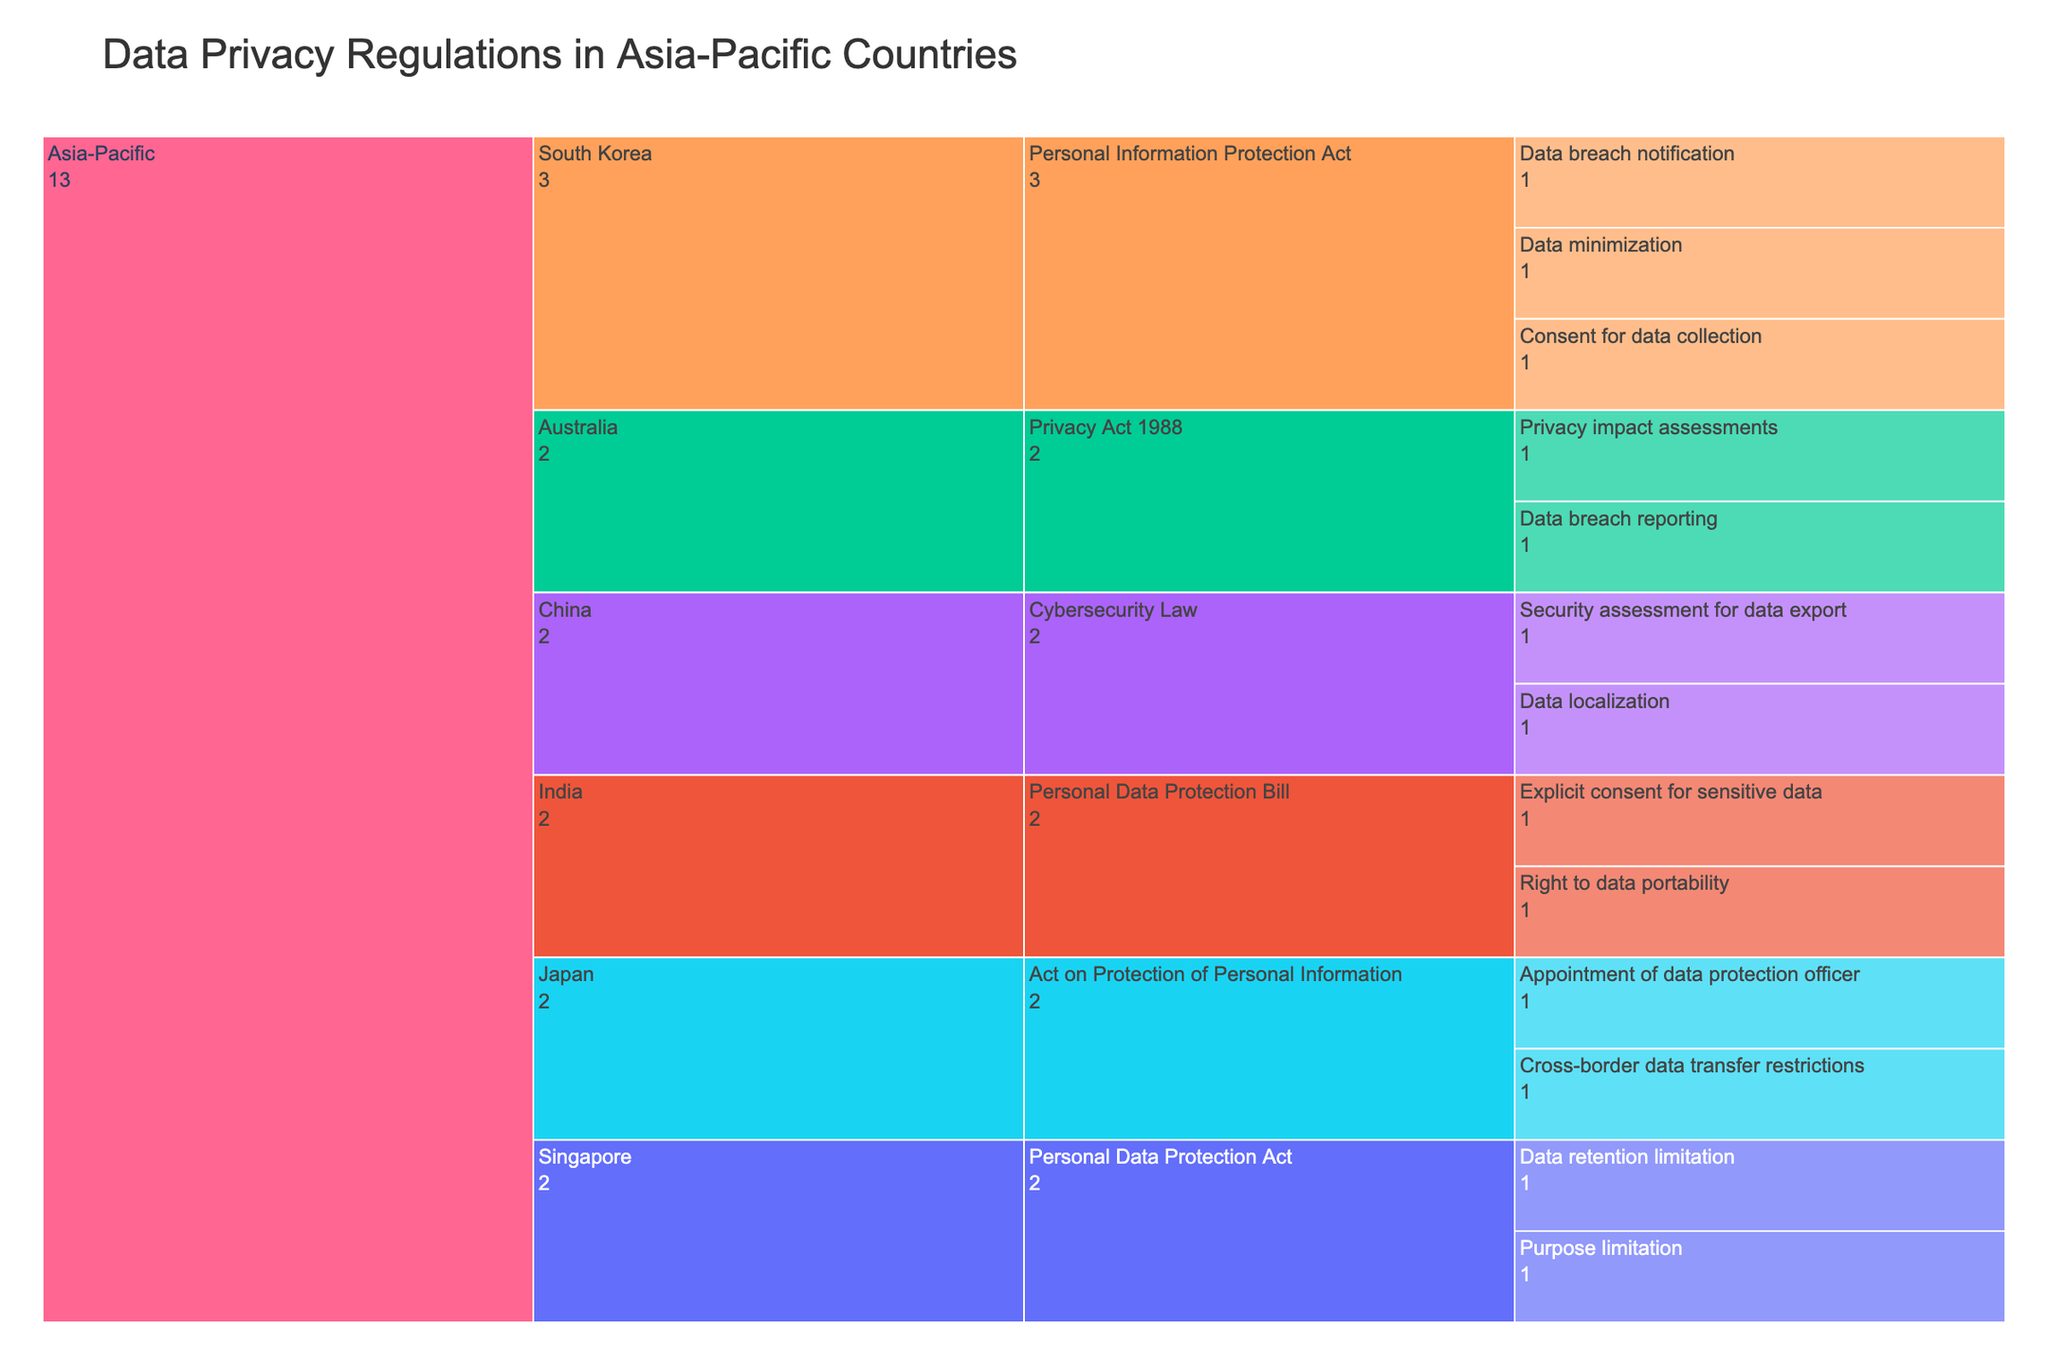What is the title of the Icicle Chart? The title is displayed at the top of the chart and typically summarizes the content it represents. This chart’s title is "Data Privacy Regulations in Asia-Pacific Countries".
Answer: Data Privacy Regulations in Asia-Pacific Countries Which country has the regulation "Personal Information Protection Act"? The chart shows regulations categorized by country. Follow the path from the Region (Asia-Pacific) to each country until you find the regulation "Personal Information Protection Act". Both South Korea and Singapore have this regulation.
Answer: South Korea, Singapore How many compliance requirements are listed under the "Cybersecurity Law" in China? Navigate to "Asia-Pacific" -> "China" -> "Cybersecurity Law" to see the compliance requirements. There are two: "Data localization" and "Security assessment for data export".
Answer: 2 Which compliance requirement is shared by the Personal Data Protection Bill in India? Follow the path from "Asia-Pacific" -> "India" -> "Personal Data Protection Bill". The compliance requirements under this regulation are "Right to data portability" and "Explicit consent for sensitive data".
Answer: Right to data portability, Explicit consent for sensitive data How many countries are covered in this Icicle Chart? Count the number of countries listed under "Asia-Pacific". The countries listed are South Korea, Japan, Singapore, Australia, China, and India.
Answer: 6 Which country has the requirement for "Privacy impact assessments"? Follow the path from "Asia-Pacific" to each country and look for the requirement "Privacy impact assessments". It is listed under "Australia" -> "Privacy Act 1988".
Answer: Australia Between South Korea and Japan, which country has more compliance requirements listed in the chart? Count the compliance requirements listed under South Korea's and Japan's regulations. South Korea has three (Data minimization, Consent for data collection, Data breach notification), and Japan has two (Appointment of data protection officer, Cross-border data transfer restrictions).
Answer: South Korea What compliance requirement is specific to China but not listed in other countries' regulations? Identify the requirements under "China" -> "Cybersecurity Law" and compare with requirements in other countries. "Data localization" is specific to China.
Answer: Data localization 